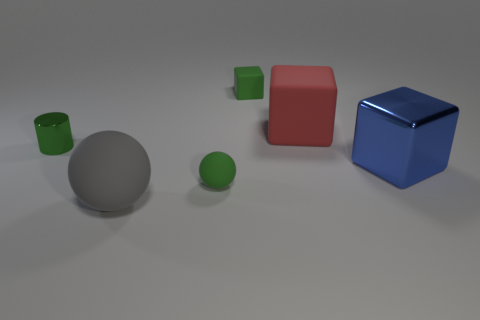Are there any other cylinders of the same size as the green metal cylinder?
Offer a terse response. No. Does the red cube have the same material as the gray ball?
Offer a terse response. Yes. What number of things are yellow shiny cubes or green shiny cylinders?
Make the answer very short. 1. What is the size of the blue thing?
Make the answer very short. Large. Is the number of tiny rubber balls less than the number of cubes?
Provide a succinct answer. Yes. What number of big objects have the same color as the small sphere?
Offer a very short reply. 0. There is a shiny thing that is to the left of the tiny rubber cube; is it the same color as the large sphere?
Provide a succinct answer. No. There is a object to the left of the large gray rubber thing; what shape is it?
Your response must be concise. Cylinder. Is there a object that is behind the green matte block behind the metallic cylinder?
Your answer should be very brief. No. What number of other tiny cubes have the same material as the small green block?
Keep it short and to the point. 0. 